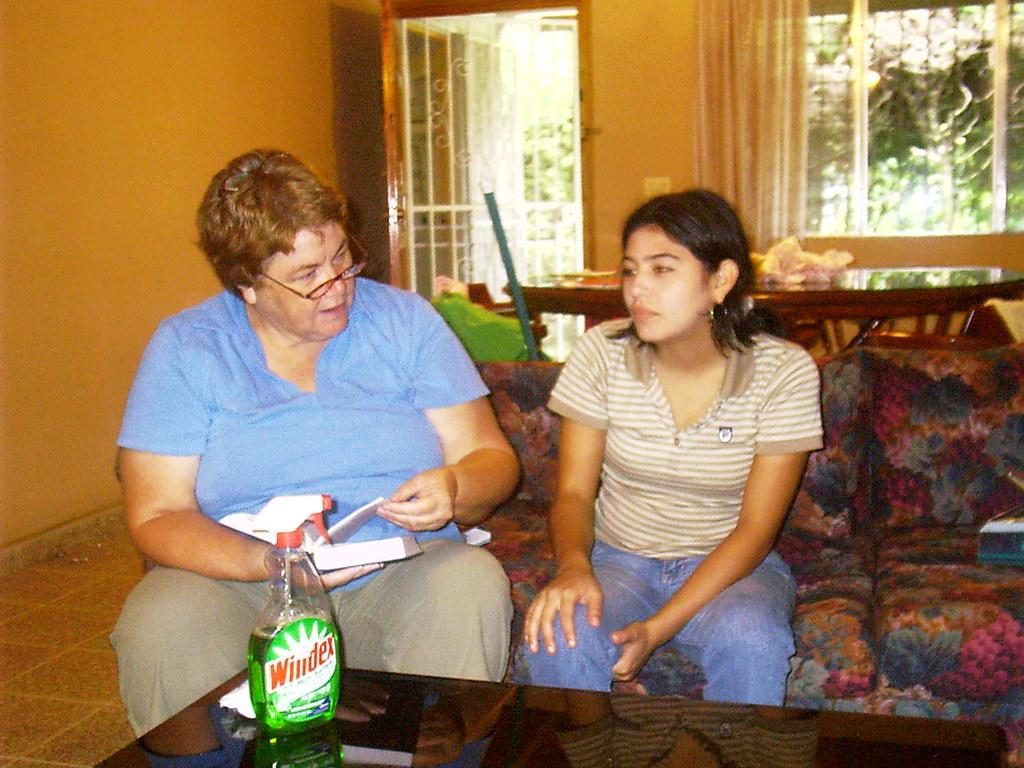What color is the wall that can be seen in the image? There is an orange color wall in the image. What feature is present on the wall? There is a window in the image. How many people are sitting on the sofa in the image? There are two people sitting on a sofa in the image. What is located in front of the sofa? There is a table in front of the sofa in the image. What object is placed on the table? There is a bottle on the table in the image. What type of bird is sitting on the skirt of the person sitting on the sofa? There is no bird or skirt present in the image. 